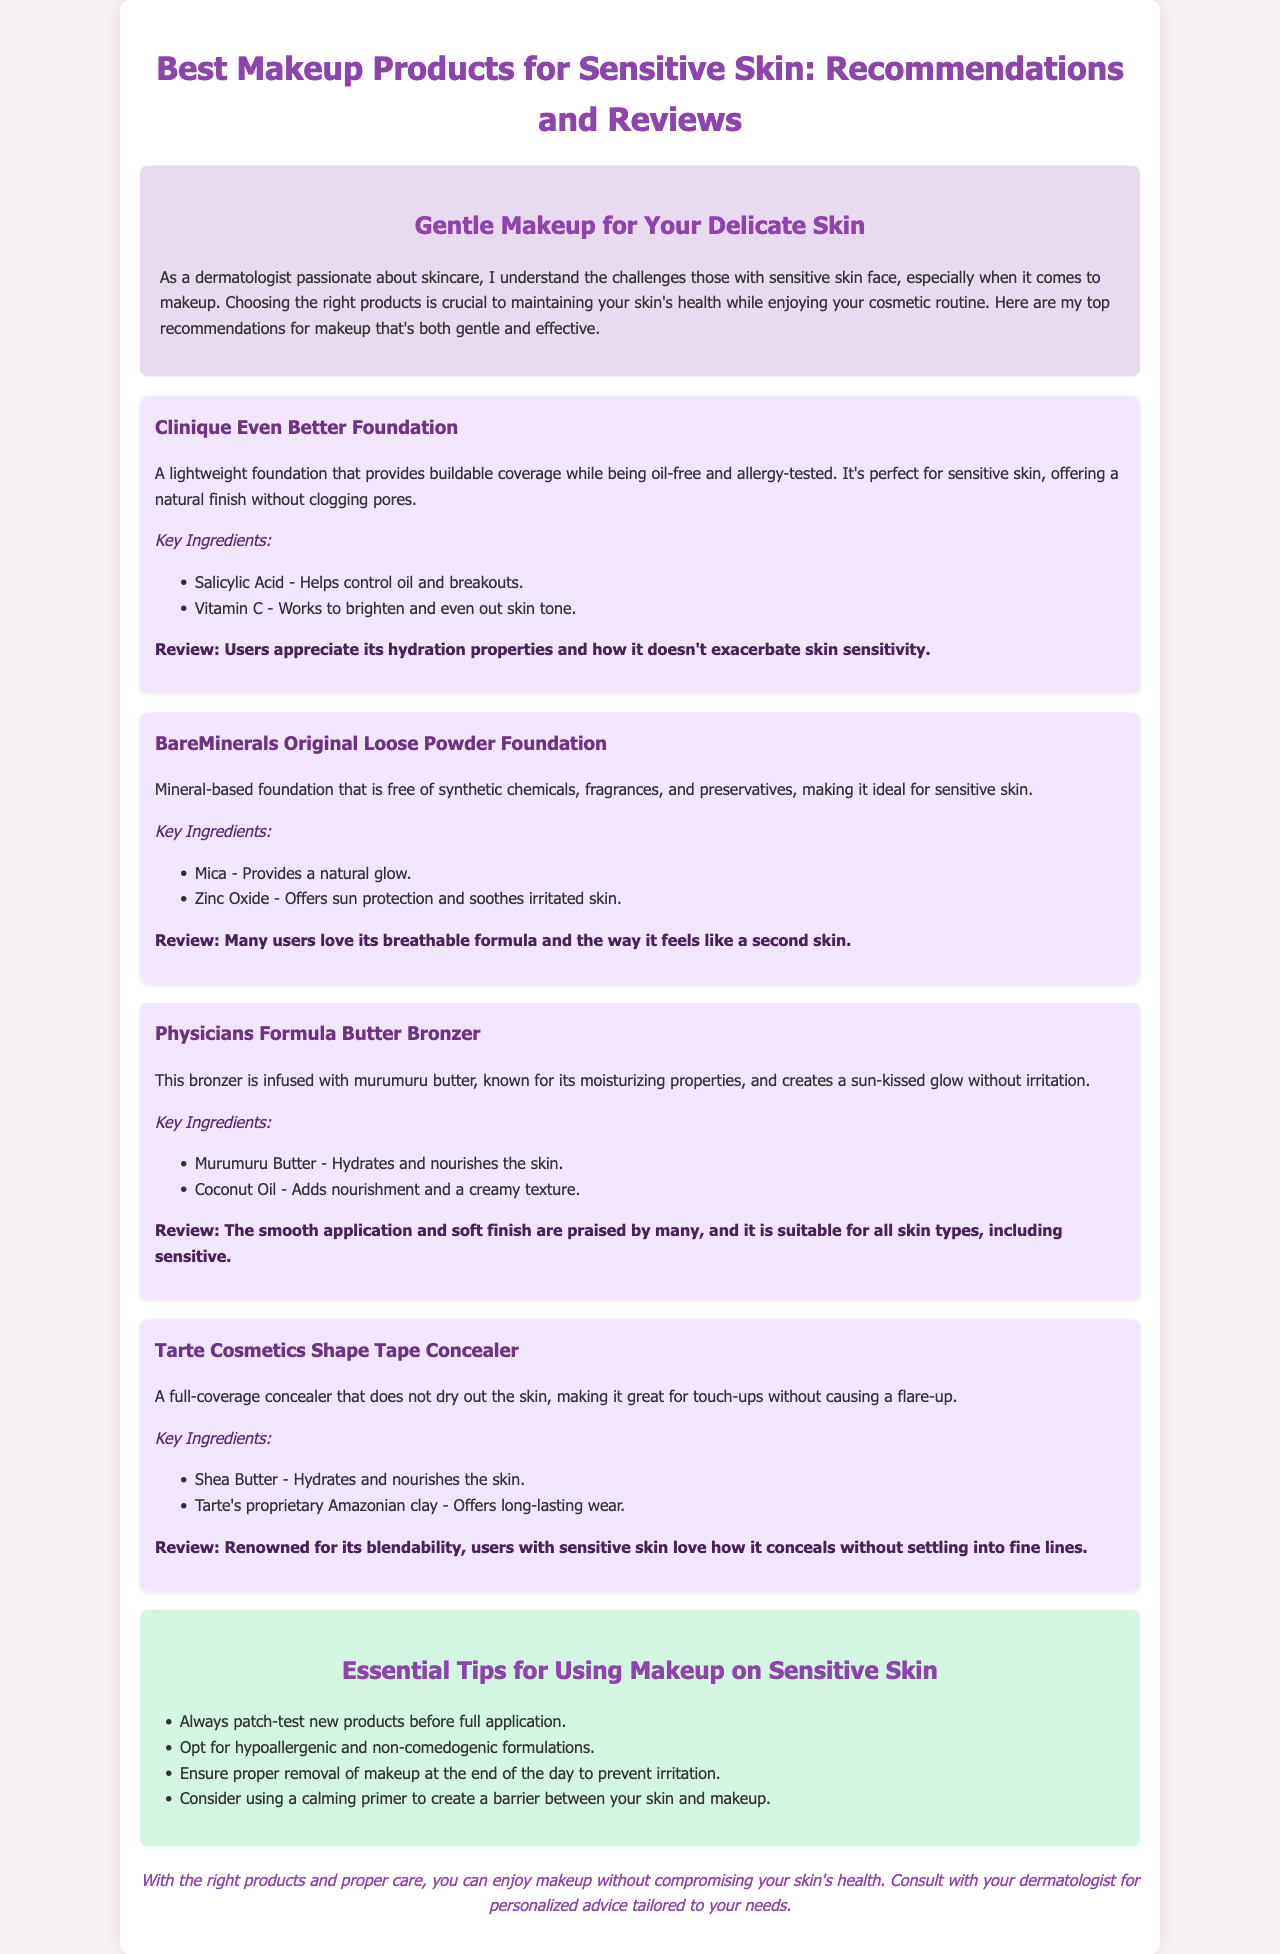What is the title of the brochure? The title is provided at the top of the document and gives an overview of its content.
Answer: Best Makeup Products for Sensitive Skin: Recommendations and Reviews What is the key ingredient in Clinique Even Better Foundation? The document lists two key ingredients for this product, which can be found in its description section.
Answer: Salicylic Acid Which foundation is noted for being mineral-based? The document describes multiple foundations and highlights one specifically characterized as mineral-based.
Answer: BareMinerals Original Loose Powder Foundation What serum is infused in Physicians Formula Butter Bronzer? The document states this bronzer contains a specific butter ingredient known for its moisturizing properties.
Answer: Murumuru Butter What is one essential tip for using makeup on sensitive skin? The document provides a list of tips, one of which highlights a precautionary measure before applying makeup.
Answer: Patch-test new products How does Tarte Cosmetics Shape Tape Concealer benefit sensitive skin users? The review section explains why this concealer is favored among users, particularly those with sensitive skin.
Answer: Does not dry out the skin What is a common theme in the reviews of the recommended products? The reviews offer insights into users' experiences and satisfaction levels with the products, reflecting a consistent point.
Answer: Suitable for sensitive skin How are the key ingredients presented in the document? The structure of the document includes specific sections for each product that lists key ingredients separately.
Answer: In a bulleted list What is the overall purpose of the brochure? The introduction section of the document explains the aim of providing users with helpful makeup recommendations suited for their skin type.
Answer: Recommendations for gentle and effective makeup 